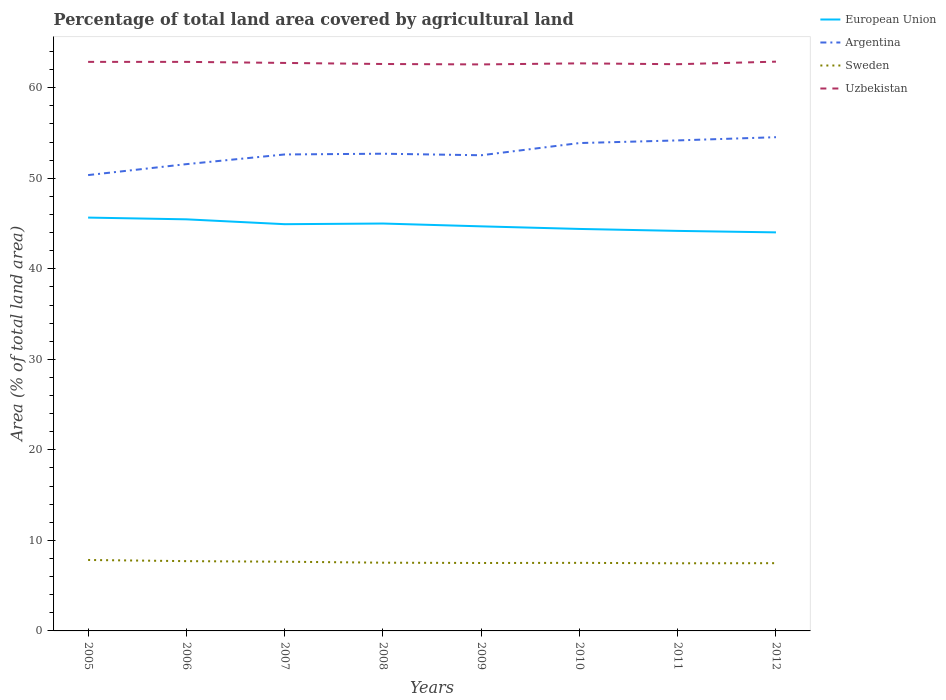Does the line corresponding to Argentina intersect with the line corresponding to Uzbekistan?
Provide a succinct answer. No. Is the number of lines equal to the number of legend labels?
Provide a short and direct response. Yes. Across all years, what is the maximum percentage of agricultural land in Uzbekistan?
Your answer should be compact. 62.58. In which year was the percentage of agricultural land in Uzbekistan maximum?
Make the answer very short. 2009. What is the total percentage of agricultural land in European Union in the graph?
Ensure brevity in your answer.  0.67. What is the difference between the highest and the second highest percentage of agricultural land in European Union?
Make the answer very short. 1.63. What is the difference between the highest and the lowest percentage of agricultural land in European Union?
Your answer should be compact. 4. How many lines are there?
Give a very brief answer. 4. What is the difference between two consecutive major ticks on the Y-axis?
Your answer should be very brief. 10. Are the values on the major ticks of Y-axis written in scientific E-notation?
Keep it short and to the point. No. Where does the legend appear in the graph?
Your answer should be compact. Top right. How are the legend labels stacked?
Give a very brief answer. Vertical. What is the title of the graph?
Provide a succinct answer. Percentage of total land area covered by agricultural land. What is the label or title of the X-axis?
Ensure brevity in your answer.  Years. What is the label or title of the Y-axis?
Offer a very short reply. Area (% of total land area). What is the Area (% of total land area) of European Union in 2005?
Keep it short and to the point. 45.66. What is the Area (% of total land area) in Argentina in 2005?
Provide a short and direct response. 50.35. What is the Area (% of total land area) of Sweden in 2005?
Offer a terse response. 7.84. What is the Area (% of total land area) in Uzbekistan in 2005?
Provide a short and direct response. 62.86. What is the Area (% of total land area) of European Union in 2006?
Your answer should be very brief. 45.47. What is the Area (% of total land area) of Argentina in 2006?
Your response must be concise. 51.56. What is the Area (% of total land area) in Sweden in 2006?
Ensure brevity in your answer.  7.71. What is the Area (% of total land area) in Uzbekistan in 2006?
Your answer should be very brief. 62.86. What is the Area (% of total land area) of European Union in 2007?
Offer a terse response. 44.93. What is the Area (% of total land area) in Argentina in 2007?
Give a very brief answer. 52.63. What is the Area (% of total land area) of Sweden in 2007?
Ensure brevity in your answer.  7.64. What is the Area (% of total land area) of Uzbekistan in 2007?
Offer a very short reply. 62.74. What is the Area (% of total land area) of European Union in 2008?
Offer a very short reply. 45. What is the Area (% of total land area) in Argentina in 2008?
Offer a terse response. 52.71. What is the Area (% of total land area) in Sweden in 2008?
Give a very brief answer. 7.54. What is the Area (% of total land area) of Uzbekistan in 2008?
Your answer should be very brief. 62.62. What is the Area (% of total land area) of European Union in 2009?
Provide a short and direct response. 44.69. What is the Area (% of total land area) of Argentina in 2009?
Make the answer very short. 52.54. What is the Area (% of total land area) of Sweden in 2009?
Your answer should be very brief. 7.5. What is the Area (% of total land area) of Uzbekistan in 2009?
Offer a terse response. 62.58. What is the Area (% of total land area) of European Union in 2010?
Offer a terse response. 44.4. What is the Area (% of total land area) in Argentina in 2010?
Make the answer very short. 53.89. What is the Area (% of total land area) in Sweden in 2010?
Your answer should be compact. 7.52. What is the Area (% of total land area) of Uzbekistan in 2010?
Give a very brief answer. 62.69. What is the Area (% of total land area) of European Union in 2011?
Offer a very short reply. 44.19. What is the Area (% of total land area) of Argentina in 2011?
Make the answer very short. 54.18. What is the Area (% of total land area) in Sweden in 2011?
Make the answer very short. 7.47. What is the Area (% of total land area) of Uzbekistan in 2011?
Ensure brevity in your answer.  62.6. What is the Area (% of total land area) in European Union in 2012?
Make the answer very short. 44.02. What is the Area (% of total land area) of Argentina in 2012?
Your answer should be very brief. 54.54. What is the Area (% of total land area) in Sweden in 2012?
Offer a very short reply. 7.48. What is the Area (% of total land area) in Uzbekistan in 2012?
Make the answer very short. 62.88. Across all years, what is the maximum Area (% of total land area) in European Union?
Keep it short and to the point. 45.66. Across all years, what is the maximum Area (% of total land area) in Argentina?
Make the answer very short. 54.54. Across all years, what is the maximum Area (% of total land area) of Sweden?
Keep it short and to the point. 7.84. Across all years, what is the maximum Area (% of total land area) of Uzbekistan?
Provide a short and direct response. 62.88. Across all years, what is the minimum Area (% of total land area) of European Union?
Make the answer very short. 44.02. Across all years, what is the minimum Area (% of total land area) of Argentina?
Give a very brief answer. 50.35. Across all years, what is the minimum Area (% of total land area) of Sweden?
Offer a very short reply. 7.47. Across all years, what is the minimum Area (% of total land area) in Uzbekistan?
Keep it short and to the point. 62.58. What is the total Area (% of total land area) of European Union in the graph?
Your response must be concise. 358.36. What is the total Area (% of total land area) in Argentina in the graph?
Your answer should be very brief. 422.41. What is the total Area (% of total land area) of Sweden in the graph?
Your response must be concise. 60.71. What is the total Area (% of total land area) in Uzbekistan in the graph?
Provide a succinct answer. 501.83. What is the difference between the Area (% of total land area) in European Union in 2005 and that in 2006?
Offer a very short reply. 0.19. What is the difference between the Area (% of total land area) in Argentina in 2005 and that in 2006?
Provide a succinct answer. -1.21. What is the difference between the Area (% of total land area) in Sweden in 2005 and that in 2006?
Provide a short and direct response. 0.13. What is the difference between the Area (% of total land area) in European Union in 2005 and that in 2007?
Provide a succinct answer. 0.73. What is the difference between the Area (% of total land area) in Argentina in 2005 and that in 2007?
Make the answer very short. -2.28. What is the difference between the Area (% of total land area) in Sweden in 2005 and that in 2007?
Your answer should be very brief. 0.19. What is the difference between the Area (% of total land area) of Uzbekistan in 2005 and that in 2007?
Keep it short and to the point. 0.12. What is the difference between the Area (% of total land area) in European Union in 2005 and that in 2008?
Give a very brief answer. 0.66. What is the difference between the Area (% of total land area) of Argentina in 2005 and that in 2008?
Your answer should be compact. -2.36. What is the difference between the Area (% of total land area) in Sweden in 2005 and that in 2008?
Your answer should be compact. 0.3. What is the difference between the Area (% of total land area) in Uzbekistan in 2005 and that in 2008?
Offer a very short reply. 0.24. What is the difference between the Area (% of total land area) in European Union in 2005 and that in 2009?
Give a very brief answer. 0.97. What is the difference between the Area (% of total land area) of Argentina in 2005 and that in 2009?
Offer a terse response. -2.19. What is the difference between the Area (% of total land area) in Sweden in 2005 and that in 2009?
Offer a very short reply. 0.33. What is the difference between the Area (% of total land area) in Uzbekistan in 2005 and that in 2009?
Give a very brief answer. 0.28. What is the difference between the Area (% of total land area) of European Union in 2005 and that in 2010?
Ensure brevity in your answer.  1.25. What is the difference between the Area (% of total land area) of Argentina in 2005 and that in 2010?
Provide a succinct answer. -3.54. What is the difference between the Area (% of total land area) of Sweden in 2005 and that in 2010?
Your response must be concise. 0.32. What is the difference between the Area (% of total land area) in Uzbekistan in 2005 and that in 2010?
Your response must be concise. 0.16. What is the difference between the Area (% of total land area) of European Union in 2005 and that in 2011?
Keep it short and to the point. 1.47. What is the difference between the Area (% of total land area) in Argentina in 2005 and that in 2011?
Give a very brief answer. -3.83. What is the difference between the Area (% of total land area) in Sweden in 2005 and that in 2011?
Provide a succinct answer. 0.37. What is the difference between the Area (% of total land area) in Uzbekistan in 2005 and that in 2011?
Ensure brevity in your answer.  0.26. What is the difference between the Area (% of total land area) in European Union in 2005 and that in 2012?
Your response must be concise. 1.63. What is the difference between the Area (% of total land area) in Argentina in 2005 and that in 2012?
Keep it short and to the point. -4.19. What is the difference between the Area (% of total land area) in Sweden in 2005 and that in 2012?
Offer a very short reply. 0.35. What is the difference between the Area (% of total land area) of Uzbekistan in 2005 and that in 2012?
Provide a succinct answer. -0.02. What is the difference between the Area (% of total land area) in European Union in 2006 and that in 2007?
Provide a succinct answer. 0.54. What is the difference between the Area (% of total land area) of Argentina in 2006 and that in 2007?
Your answer should be compact. -1.07. What is the difference between the Area (% of total land area) in Sweden in 2006 and that in 2007?
Offer a terse response. 0.06. What is the difference between the Area (% of total land area) of Uzbekistan in 2006 and that in 2007?
Offer a very short reply. 0.12. What is the difference between the Area (% of total land area) of European Union in 2006 and that in 2008?
Provide a short and direct response. 0.46. What is the difference between the Area (% of total land area) in Argentina in 2006 and that in 2008?
Keep it short and to the point. -1.15. What is the difference between the Area (% of total land area) in Sweden in 2006 and that in 2008?
Provide a short and direct response. 0.17. What is the difference between the Area (% of total land area) in Uzbekistan in 2006 and that in 2008?
Make the answer very short. 0.24. What is the difference between the Area (% of total land area) in European Union in 2006 and that in 2009?
Offer a terse response. 0.78. What is the difference between the Area (% of total land area) in Argentina in 2006 and that in 2009?
Offer a very short reply. -0.98. What is the difference between the Area (% of total land area) of Sweden in 2006 and that in 2009?
Offer a very short reply. 0.2. What is the difference between the Area (% of total land area) in Uzbekistan in 2006 and that in 2009?
Keep it short and to the point. 0.28. What is the difference between the Area (% of total land area) of European Union in 2006 and that in 2010?
Keep it short and to the point. 1.06. What is the difference between the Area (% of total land area) of Argentina in 2006 and that in 2010?
Offer a very short reply. -2.33. What is the difference between the Area (% of total land area) of Sweden in 2006 and that in 2010?
Provide a short and direct response. 0.19. What is the difference between the Area (% of total land area) in Uzbekistan in 2006 and that in 2010?
Ensure brevity in your answer.  0.16. What is the difference between the Area (% of total land area) in European Union in 2006 and that in 2011?
Your response must be concise. 1.28. What is the difference between the Area (% of total land area) in Argentina in 2006 and that in 2011?
Ensure brevity in your answer.  -2.62. What is the difference between the Area (% of total land area) in Sweden in 2006 and that in 2011?
Ensure brevity in your answer.  0.24. What is the difference between the Area (% of total land area) in Uzbekistan in 2006 and that in 2011?
Your answer should be very brief. 0.26. What is the difference between the Area (% of total land area) in European Union in 2006 and that in 2012?
Ensure brevity in your answer.  1.44. What is the difference between the Area (% of total land area) of Argentina in 2006 and that in 2012?
Make the answer very short. -2.98. What is the difference between the Area (% of total land area) of Sweden in 2006 and that in 2012?
Your answer should be very brief. 0.22. What is the difference between the Area (% of total land area) of Uzbekistan in 2006 and that in 2012?
Offer a very short reply. -0.02. What is the difference between the Area (% of total land area) of European Union in 2007 and that in 2008?
Provide a succinct answer. -0.07. What is the difference between the Area (% of total land area) in Argentina in 2007 and that in 2008?
Your response must be concise. -0.08. What is the difference between the Area (% of total land area) in Sweden in 2007 and that in 2008?
Your answer should be compact. 0.11. What is the difference between the Area (% of total land area) in Uzbekistan in 2007 and that in 2008?
Offer a very short reply. 0.12. What is the difference between the Area (% of total land area) in European Union in 2007 and that in 2009?
Keep it short and to the point. 0.24. What is the difference between the Area (% of total land area) in Argentina in 2007 and that in 2009?
Your answer should be very brief. 0.09. What is the difference between the Area (% of total land area) in Sweden in 2007 and that in 2009?
Provide a short and direct response. 0.14. What is the difference between the Area (% of total land area) in Uzbekistan in 2007 and that in 2009?
Your response must be concise. 0.16. What is the difference between the Area (% of total land area) of European Union in 2007 and that in 2010?
Provide a succinct answer. 0.52. What is the difference between the Area (% of total land area) of Argentina in 2007 and that in 2010?
Your response must be concise. -1.26. What is the difference between the Area (% of total land area) in Sweden in 2007 and that in 2010?
Your answer should be compact. 0.13. What is the difference between the Area (% of total land area) in Uzbekistan in 2007 and that in 2010?
Your answer should be compact. 0.05. What is the difference between the Area (% of total land area) in European Union in 2007 and that in 2011?
Your answer should be very brief. 0.74. What is the difference between the Area (% of total land area) of Argentina in 2007 and that in 2011?
Provide a short and direct response. -1.55. What is the difference between the Area (% of total land area) in Sweden in 2007 and that in 2011?
Offer a terse response. 0.17. What is the difference between the Area (% of total land area) in Uzbekistan in 2007 and that in 2011?
Keep it short and to the point. 0.14. What is the difference between the Area (% of total land area) in European Union in 2007 and that in 2012?
Offer a terse response. 0.9. What is the difference between the Area (% of total land area) of Argentina in 2007 and that in 2012?
Ensure brevity in your answer.  -1.91. What is the difference between the Area (% of total land area) in Sweden in 2007 and that in 2012?
Provide a succinct answer. 0.16. What is the difference between the Area (% of total land area) of Uzbekistan in 2007 and that in 2012?
Make the answer very short. -0.14. What is the difference between the Area (% of total land area) of European Union in 2008 and that in 2009?
Your response must be concise. 0.31. What is the difference between the Area (% of total land area) of Argentina in 2008 and that in 2009?
Provide a short and direct response. 0.17. What is the difference between the Area (% of total land area) in Sweden in 2008 and that in 2009?
Your response must be concise. 0.03. What is the difference between the Area (% of total land area) of Uzbekistan in 2008 and that in 2009?
Offer a very short reply. 0.05. What is the difference between the Area (% of total land area) in European Union in 2008 and that in 2010?
Keep it short and to the point. 0.6. What is the difference between the Area (% of total land area) in Argentina in 2008 and that in 2010?
Give a very brief answer. -1.18. What is the difference between the Area (% of total land area) of Sweden in 2008 and that in 2010?
Your response must be concise. 0.02. What is the difference between the Area (% of total land area) of Uzbekistan in 2008 and that in 2010?
Give a very brief answer. -0.07. What is the difference between the Area (% of total land area) in European Union in 2008 and that in 2011?
Make the answer very short. 0.81. What is the difference between the Area (% of total land area) in Argentina in 2008 and that in 2011?
Keep it short and to the point. -1.47. What is the difference between the Area (% of total land area) of Sweden in 2008 and that in 2011?
Your response must be concise. 0.07. What is the difference between the Area (% of total land area) of Uzbekistan in 2008 and that in 2011?
Provide a short and direct response. 0.02. What is the difference between the Area (% of total land area) in European Union in 2008 and that in 2012?
Provide a short and direct response. 0.98. What is the difference between the Area (% of total land area) in Argentina in 2008 and that in 2012?
Your answer should be very brief. -1.82. What is the difference between the Area (% of total land area) of Sweden in 2008 and that in 2012?
Offer a terse response. 0.05. What is the difference between the Area (% of total land area) of Uzbekistan in 2008 and that in 2012?
Provide a short and direct response. -0.26. What is the difference between the Area (% of total land area) in European Union in 2009 and that in 2010?
Make the answer very short. 0.29. What is the difference between the Area (% of total land area) in Argentina in 2009 and that in 2010?
Make the answer very short. -1.35. What is the difference between the Area (% of total land area) in Sweden in 2009 and that in 2010?
Your answer should be very brief. -0.01. What is the difference between the Area (% of total land area) in Uzbekistan in 2009 and that in 2010?
Give a very brief answer. -0.12. What is the difference between the Area (% of total land area) in European Union in 2009 and that in 2011?
Ensure brevity in your answer.  0.5. What is the difference between the Area (% of total land area) in Argentina in 2009 and that in 2011?
Give a very brief answer. -1.64. What is the difference between the Area (% of total land area) in Sweden in 2009 and that in 2011?
Ensure brevity in your answer.  0.03. What is the difference between the Area (% of total land area) of Uzbekistan in 2009 and that in 2011?
Provide a short and direct response. -0.02. What is the difference between the Area (% of total land area) in European Union in 2009 and that in 2012?
Give a very brief answer. 0.67. What is the difference between the Area (% of total land area) in Argentina in 2009 and that in 2012?
Offer a very short reply. -2. What is the difference between the Area (% of total land area) of Sweden in 2009 and that in 2012?
Your response must be concise. 0.02. What is the difference between the Area (% of total land area) in Uzbekistan in 2009 and that in 2012?
Your answer should be compact. -0.31. What is the difference between the Area (% of total land area) of European Union in 2010 and that in 2011?
Provide a succinct answer. 0.22. What is the difference between the Area (% of total land area) of Argentina in 2010 and that in 2011?
Provide a succinct answer. -0.29. What is the difference between the Area (% of total land area) in Sweden in 2010 and that in 2011?
Provide a succinct answer. 0.05. What is the difference between the Area (% of total land area) in Uzbekistan in 2010 and that in 2011?
Offer a terse response. 0.09. What is the difference between the Area (% of total land area) of European Union in 2010 and that in 2012?
Ensure brevity in your answer.  0.38. What is the difference between the Area (% of total land area) in Argentina in 2010 and that in 2012?
Give a very brief answer. -0.65. What is the difference between the Area (% of total land area) in Sweden in 2010 and that in 2012?
Provide a succinct answer. 0.03. What is the difference between the Area (% of total land area) in Uzbekistan in 2010 and that in 2012?
Provide a succinct answer. -0.19. What is the difference between the Area (% of total land area) in European Union in 2011 and that in 2012?
Offer a very short reply. 0.16. What is the difference between the Area (% of total land area) of Argentina in 2011 and that in 2012?
Ensure brevity in your answer.  -0.36. What is the difference between the Area (% of total land area) in Sweden in 2011 and that in 2012?
Make the answer very short. -0.01. What is the difference between the Area (% of total land area) in Uzbekistan in 2011 and that in 2012?
Ensure brevity in your answer.  -0.28. What is the difference between the Area (% of total land area) of European Union in 2005 and the Area (% of total land area) of Argentina in 2006?
Offer a terse response. -5.9. What is the difference between the Area (% of total land area) of European Union in 2005 and the Area (% of total land area) of Sweden in 2006?
Offer a terse response. 37.95. What is the difference between the Area (% of total land area) of European Union in 2005 and the Area (% of total land area) of Uzbekistan in 2006?
Give a very brief answer. -17.2. What is the difference between the Area (% of total land area) of Argentina in 2005 and the Area (% of total land area) of Sweden in 2006?
Ensure brevity in your answer.  42.64. What is the difference between the Area (% of total land area) of Argentina in 2005 and the Area (% of total land area) of Uzbekistan in 2006?
Your answer should be very brief. -12.51. What is the difference between the Area (% of total land area) of Sweden in 2005 and the Area (% of total land area) of Uzbekistan in 2006?
Make the answer very short. -55.02. What is the difference between the Area (% of total land area) of European Union in 2005 and the Area (% of total land area) of Argentina in 2007?
Your answer should be very brief. -6.97. What is the difference between the Area (% of total land area) in European Union in 2005 and the Area (% of total land area) in Sweden in 2007?
Ensure brevity in your answer.  38.01. What is the difference between the Area (% of total land area) in European Union in 2005 and the Area (% of total land area) in Uzbekistan in 2007?
Offer a very short reply. -17.08. What is the difference between the Area (% of total land area) in Argentina in 2005 and the Area (% of total land area) in Sweden in 2007?
Provide a succinct answer. 42.71. What is the difference between the Area (% of total land area) of Argentina in 2005 and the Area (% of total land area) of Uzbekistan in 2007?
Make the answer very short. -12.39. What is the difference between the Area (% of total land area) of Sweden in 2005 and the Area (% of total land area) of Uzbekistan in 2007?
Keep it short and to the point. -54.9. What is the difference between the Area (% of total land area) of European Union in 2005 and the Area (% of total land area) of Argentina in 2008?
Offer a terse response. -7.06. What is the difference between the Area (% of total land area) in European Union in 2005 and the Area (% of total land area) in Sweden in 2008?
Provide a short and direct response. 38.12. What is the difference between the Area (% of total land area) in European Union in 2005 and the Area (% of total land area) in Uzbekistan in 2008?
Offer a terse response. -16.97. What is the difference between the Area (% of total land area) in Argentina in 2005 and the Area (% of total land area) in Sweden in 2008?
Give a very brief answer. 42.81. What is the difference between the Area (% of total land area) of Argentina in 2005 and the Area (% of total land area) of Uzbekistan in 2008?
Make the answer very short. -12.27. What is the difference between the Area (% of total land area) in Sweden in 2005 and the Area (% of total land area) in Uzbekistan in 2008?
Your response must be concise. -54.79. What is the difference between the Area (% of total land area) in European Union in 2005 and the Area (% of total land area) in Argentina in 2009?
Make the answer very short. -6.88. What is the difference between the Area (% of total land area) of European Union in 2005 and the Area (% of total land area) of Sweden in 2009?
Offer a very short reply. 38.15. What is the difference between the Area (% of total land area) in European Union in 2005 and the Area (% of total land area) in Uzbekistan in 2009?
Your answer should be compact. -16.92. What is the difference between the Area (% of total land area) in Argentina in 2005 and the Area (% of total land area) in Sweden in 2009?
Your answer should be very brief. 42.85. What is the difference between the Area (% of total land area) of Argentina in 2005 and the Area (% of total land area) of Uzbekistan in 2009?
Give a very brief answer. -12.22. What is the difference between the Area (% of total land area) of Sweden in 2005 and the Area (% of total land area) of Uzbekistan in 2009?
Make the answer very short. -54.74. What is the difference between the Area (% of total land area) in European Union in 2005 and the Area (% of total land area) in Argentina in 2010?
Your answer should be very brief. -8.23. What is the difference between the Area (% of total land area) in European Union in 2005 and the Area (% of total land area) in Sweden in 2010?
Offer a terse response. 38.14. What is the difference between the Area (% of total land area) in European Union in 2005 and the Area (% of total land area) in Uzbekistan in 2010?
Ensure brevity in your answer.  -17.04. What is the difference between the Area (% of total land area) of Argentina in 2005 and the Area (% of total land area) of Sweden in 2010?
Your answer should be compact. 42.83. What is the difference between the Area (% of total land area) of Argentina in 2005 and the Area (% of total land area) of Uzbekistan in 2010?
Keep it short and to the point. -12.34. What is the difference between the Area (% of total land area) in Sweden in 2005 and the Area (% of total land area) in Uzbekistan in 2010?
Offer a very short reply. -54.86. What is the difference between the Area (% of total land area) of European Union in 2005 and the Area (% of total land area) of Argentina in 2011?
Keep it short and to the point. -8.52. What is the difference between the Area (% of total land area) of European Union in 2005 and the Area (% of total land area) of Sweden in 2011?
Offer a terse response. 38.19. What is the difference between the Area (% of total land area) in European Union in 2005 and the Area (% of total land area) in Uzbekistan in 2011?
Offer a very short reply. -16.94. What is the difference between the Area (% of total land area) of Argentina in 2005 and the Area (% of total land area) of Sweden in 2011?
Your answer should be very brief. 42.88. What is the difference between the Area (% of total land area) of Argentina in 2005 and the Area (% of total land area) of Uzbekistan in 2011?
Keep it short and to the point. -12.25. What is the difference between the Area (% of total land area) of Sweden in 2005 and the Area (% of total land area) of Uzbekistan in 2011?
Provide a short and direct response. -54.76. What is the difference between the Area (% of total land area) in European Union in 2005 and the Area (% of total land area) in Argentina in 2012?
Keep it short and to the point. -8.88. What is the difference between the Area (% of total land area) in European Union in 2005 and the Area (% of total land area) in Sweden in 2012?
Offer a very short reply. 38.17. What is the difference between the Area (% of total land area) of European Union in 2005 and the Area (% of total land area) of Uzbekistan in 2012?
Provide a short and direct response. -17.22. What is the difference between the Area (% of total land area) in Argentina in 2005 and the Area (% of total land area) in Sweden in 2012?
Give a very brief answer. 42.87. What is the difference between the Area (% of total land area) in Argentina in 2005 and the Area (% of total land area) in Uzbekistan in 2012?
Your answer should be compact. -12.53. What is the difference between the Area (% of total land area) in Sweden in 2005 and the Area (% of total land area) in Uzbekistan in 2012?
Ensure brevity in your answer.  -55.04. What is the difference between the Area (% of total land area) in European Union in 2006 and the Area (% of total land area) in Argentina in 2007?
Offer a very short reply. -7.17. What is the difference between the Area (% of total land area) of European Union in 2006 and the Area (% of total land area) of Sweden in 2007?
Ensure brevity in your answer.  37.82. What is the difference between the Area (% of total land area) of European Union in 2006 and the Area (% of total land area) of Uzbekistan in 2007?
Your answer should be compact. -17.28. What is the difference between the Area (% of total land area) in Argentina in 2006 and the Area (% of total land area) in Sweden in 2007?
Your response must be concise. 43.92. What is the difference between the Area (% of total land area) of Argentina in 2006 and the Area (% of total land area) of Uzbekistan in 2007?
Your response must be concise. -11.18. What is the difference between the Area (% of total land area) of Sweden in 2006 and the Area (% of total land area) of Uzbekistan in 2007?
Offer a very short reply. -55.03. What is the difference between the Area (% of total land area) in European Union in 2006 and the Area (% of total land area) in Argentina in 2008?
Ensure brevity in your answer.  -7.25. What is the difference between the Area (% of total land area) in European Union in 2006 and the Area (% of total land area) in Sweden in 2008?
Your answer should be compact. 37.93. What is the difference between the Area (% of total land area) of European Union in 2006 and the Area (% of total land area) of Uzbekistan in 2008?
Provide a succinct answer. -17.16. What is the difference between the Area (% of total land area) of Argentina in 2006 and the Area (% of total land area) of Sweden in 2008?
Offer a terse response. 44.02. What is the difference between the Area (% of total land area) of Argentina in 2006 and the Area (% of total land area) of Uzbekistan in 2008?
Your answer should be very brief. -11.06. What is the difference between the Area (% of total land area) in Sweden in 2006 and the Area (% of total land area) in Uzbekistan in 2008?
Make the answer very short. -54.92. What is the difference between the Area (% of total land area) of European Union in 2006 and the Area (% of total land area) of Argentina in 2009?
Give a very brief answer. -7.08. What is the difference between the Area (% of total land area) of European Union in 2006 and the Area (% of total land area) of Sweden in 2009?
Provide a short and direct response. 37.96. What is the difference between the Area (% of total land area) of European Union in 2006 and the Area (% of total land area) of Uzbekistan in 2009?
Provide a short and direct response. -17.11. What is the difference between the Area (% of total land area) of Argentina in 2006 and the Area (% of total land area) of Sweden in 2009?
Ensure brevity in your answer.  44.06. What is the difference between the Area (% of total land area) of Argentina in 2006 and the Area (% of total land area) of Uzbekistan in 2009?
Keep it short and to the point. -11.02. What is the difference between the Area (% of total land area) in Sweden in 2006 and the Area (% of total land area) in Uzbekistan in 2009?
Make the answer very short. -54.87. What is the difference between the Area (% of total land area) of European Union in 2006 and the Area (% of total land area) of Argentina in 2010?
Offer a very short reply. -8.43. What is the difference between the Area (% of total land area) of European Union in 2006 and the Area (% of total land area) of Sweden in 2010?
Offer a very short reply. 37.95. What is the difference between the Area (% of total land area) in European Union in 2006 and the Area (% of total land area) in Uzbekistan in 2010?
Ensure brevity in your answer.  -17.23. What is the difference between the Area (% of total land area) in Argentina in 2006 and the Area (% of total land area) in Sweden in 2010?
Ensure brevity in your answer.  44.04. What is the difference between the Area (% of total land area) of Argentina in 2006 and the Area (% of total land area) of Uzbekistan in 2010?
Your answer should be compact. -11.13. What is the difference between the Area (% of total land area) in Sweden in 2006 and the Area (% of total land area) in Uzbekistan in 2010?
Ensure brevity in your answer.  -54.99. What is the difference between the Area (% of total land area) of European Union in 2006 and the Area (% of total land area) of Argentina in 2011?
Provide a short and direct response. -8.72. What is the difference between the Area (% of total land area) of European Union in 2006 and the Area (% of total land area) of Sweden in 2011?
Give a very brief answer. 37.99. What is the difference between the Area (% of total land area) in European Union in 2006 and the Area (% of total land area) in Uzbekistan in 2011?
Your response must be concise. -17.13. What is the difference between the Area (% of total land area) of Argentina in 2006 and the Area (% of total land area) of Sweden in 2011?
Offer a terse response. 44.09. What is the difference between the Area (% of total land area) of Argentina in 2006 and the Area (% of total land area) of Uzbekistan in 2011?
Offer a very short reply. -11.04. What is the difference between the Area (% of total land area) of Sweden in 2006 and the Area (% of total land area) of Uzbekistan in 2011?
Offer a terse response. -54.89. What is the difference between the Area (% of total land area) in European Union in 2006 and the Area (% of total land area) in Argentina in 2012?
Keep it short and to the point. -9.07. What is the difference between the Area (% of total land area) in European Union in 2006 and the Area (% of total land area) in Sweden in 2012?
Give a very brief answer. 37.98. What is the difference between the Area (% of total land area) in European Union in 2006 and the Area (% of total land area) in Uzbekistan in 2012?
Make the answer very short. -17.42. What is the difference between the Area (% of total land area) in Argentina in 2006 and the Area (% of total land area) in Sweden in 2012?
Your answer should be compact. 44.08. What is the difference between the Area (% of total land area) in Argentina in 2006 and the Area (% of total land area) in Uzbekistan in 2012?
Offer a terse response. -11.32. What is the difference between the Area (% of total land area) in Sweden in 2006 and the Area (% of total land area) in Uzbekistan in 2012?
Your answer should be compact. -55.17. What is the difference between the Area (% of total land area) in European Union in 2007 and the Area (% of total land area) in Argentina in 2008?
Ensure brevity in your answer.  -7.79. What is the difference between the Area (% of total land area) in European Union in 2007 and the Area (% of total land area) in Sweden in 2008?
Your response must be concise. 37.39. What is the difference between the Area (% of total land area) of European Union in 2007 and the Area (% of total land area) of Uzbekistan in 2008?
Your response must be concise. -17.7. What is the difference between the Area (% of total land area) of Argentina in 2007 and the Area (% of total land area) of Sweden in 2008?
Your answer should be compact. 45.09. What is the difference between the Area (% of total land area) of Argentina in 2007 and the Area (% of total land area) of Uzbekistan in 2008?
Provide a short and direct response. -9.99. What is the difference between the Area (% of total land area) in Sweden in 2007 and the Area (% of total land area) in Uzbekistan in 2008?
Keep it short and to the point. -54.98. What is the difference between the Area (% of total land area) of European Union in 2007 and the Area (% of total land area) of Argentina in 2009?
Make the answer very short. -7.61. What is the difference between the Area (% of total land area) of European Union in 2007 and the Area (% of total land area) of Sweden in 2009?
Provide a short and direct response. 37.42. What is the difference between the Area (% of total land area) of European Union in 2007 and the Area (% of total land area) of Uzbekistan in 2009?
Keep it short and to the point. -17.65. What is the difference between the Area (% of total land area) in Argentina in 2007 and the Area (% of total land area) in Sweden in 2009?
Provide a short and direct response. 45.13. What is the difference between the Area (% of total land area) in Argentina in 2007 and the Area (% of total land area) in Uzbekistan in 2009?
Your answer should be compact. -9.95. What is the difference between the Area (% of total land area) of Sweden in 2007 and the Area (% of total land area) of Uzbekistan in 2009?
Keep it short and to the point. -54.93. What is the difference between the Area (% of total land area) in European Union in 2007 and the Area (% of total land area) in Argentina in 2010?
Offer a terse response. -8.96. What is the difference between the Area (% of total land area) of European Union in 2007 and the Area (% of total land area) of Sweden in 2010?
Provide a short and direct response. 37.41. What is the difference between the Area (% of total land area) of European Union in 2007 and the Area (% of total land area) of Uzbekistan in 2010?
Offer a terse response. -17.77. What is the difference between the Area (% of total land area) of Argentina in 2007 and the Area (% of total land area) of Sweden in 2010?
Ensure brevity in your answer.  45.11. What is the difference between the Area (% of total land area) of Argentina in 2007 and the Area (% of total land area) of Uzbekistan in 2010?
Provide a short and direct response. -10.06. What is the difference between the Area (% of total land area) in Sweden in 2007 and the Area (% of total land area) in Uzbekistan in 2010?
Ensure brevity in your answer.  -55.05. What is the difference between the Area (% of total land area) in European Union in 2007 and the Area (% of total land area) in Argentina in 2011?
Ensure brevity in your answer.  -9.25. What is the difference between the Area (% of total land area) in European Union in 2007 and the Area (% of total land area) in Sweden in 2011?
Provide a succinct answer. 37.46. What is the difference between the Area (% of total land area) of European Union in 2007 and the Area (% of total land area) of Uzbekistan in 2011?
Provide a short and direct response. -17.67. What is the difference between the Area (% of total land area) in Argentina in 2007 and the Area (% of total land area) in Sweden in 2011?
Make the answer very short. 45.16. What is the difference between the Area (% of total land area) of Argentina in 2007 and the Area (% of total land area) of Uzbekistan in 2011?
Ensure brevity in your answer.  -9.97. What is the difference between the Area (% of total land area) in Sweden in 2007 and the Area (% of total land area) in Uzbekistan in 2011?
Provide a succinct answer. -54.95. What is the difference between the Area (% of total land area) in European Union in 2007 and the Area (% of total land area) in Argentina in 2012?
Make the answer very short. -9.61. What is the difference between the Area (% of total land area) of European Union in 2007 and the Area (% of total land area) of Sweden in 2012?
Ensure brevity in your answer.  37.44. What is the difference between the Area (% of total land area) in European Union in 2007 and the Area (% of total land area) in Uzbekistan in 2012?
Your answer should be compact. -17.95. What is the difference between the Area (% of total land area) in Argentina in 2007 and the Area (% of total land area) in Sweden in 2012?
Keep it short and to the point. 45.15. What is the difference between the Area (% of total land area) of Argentina in 2007 and the Area (% of total land area) of Uzbekistan in 2012?
Provide a succinct answer. -10.25. What is the difference between the Area (% of total land area) of Sweden in 2007 and the Area (% of total land area) of Uzbekistan in 2012?
Offer a very short reply. -55.24. What is the difference between the Area (% of total land area) in European Union in 2008 and the Area (% of total land area) in Argentina in 2009?
Make the answer very short. -7.54. What is the difference between the Area (% of total land area) in European Union in 2008 and the Area (% of total land area) in Sweden in 2009?
Provide a succinct answer. 37.5. What is the difference between the Area (% of total land area) in European Union in 2008 and the Area (% of total land area) in Uzbekistan in 2009?
Offer a very short reply. -17.58. What is the difference between the Area (% of total land area) of Argentina in 2008 and the Area (% of total land area) of Sweden in 2009?
Keep it short and to the point. 45.21. What is the difference between the Area (% of total land area) in Argentina in 2008 and the Area (% of total land area) in Uzbekistan in 2009?
Give a very brief answer. -9.86. What is the difference between the Area (% of total land area) of Sweden in 2008 and the Area (% of total land area) of Uzbekistan in 2009?
Offer a very short reply. -55.04. What is the difference between the Area (% of total land area) in European Union in 2008 and the Area (% of total land area) in Argentina in 2010?
Provide a short and direct response. -8.89. What is the difference between the Area (% of total land area) in European Union in 2008 and the Area (% of total land area) in Sweden in 2010?
Give a very brief answer. 37.48. What is the difference between the Area (% of total land area) in European Union in 2008 and the Area (% of total land area) in Uzbekistan in 2010?
Provide a succinct answer. -17.69. What is the difference between the Area (% of total land area) of Argentina in 2008 and the Area (% of total land area) of Sweden in 2010?
Give a very brief answer. 45.2. What is the difference between the Area (% of total land area) in Argentina in 2008 and the Area (% of total land area) in Uzbekistan in 2010?
Your answer should be compact. -9.98. What is the difference between the Area (% of total land area) of Sweden in 2008 and the Area (% of total land area) of Uzbekistan in 2010?
Your answer should be compact. -55.16. What is the difference between the Area (% of total land area) of European Union in 2008 and the Area (% of total land area) of Argentina in 2011?
Your response must be concise. -9.18. What is the difference between the Area (% of total land area) in European Union in 2008 and the Area (% of total land area) in Sweden in 2011?
Provide a short and direct response. 37.53. What is the difference between the Area (% of total land area) of European Union in 2008 and the Area (% of total land area) of Uzbekistan in 2011?
Keep it short and to the point. -17.6. What is the difference between the Area (% of total land area) of Argentina in 2008 and the Area (% of total land area) of Sweden in 2011?
Offer a terse response. 45.24. What is the difference between the Area (% of total land area) in Argentina in 2008 and the Area (% of total land area) in Uzbekistan in 2011?
Ensure brevity in your answer.  -9.89. What is the difference between the Area (% of total land area) of Sweden in 2008 and the Area (% of total land area) of Uzbekistan in 2011?
Offer a very short reply. -55.06. What is the difference between the Area (% of total land area) of European Union in 2008 and the Area (% of total land area) of Argentina in 2012?
Your answer should be compact. -9.54. What is the difference between the Area (% of total land area) in European Union in 2008 and the Area (% of total land area) in Sweden in 2012?
Offer a terse response. 37.52. What is the difference between the Area (% of total land area) of European Union in 2008 and the Area (% of total land area) of Uzbekistan in 2012?
Keep it short and to the point. -17.88. What is the difference between the Area (% of total land area) of Argentina in 2008 and the Area (% of total land area) of Sweden in 2012?
Offer a terse response. 45.23. What is the difference between the Area (% of total land area) in Argentina in 2008 and the Area (% of total land area) in Uzbekistan in 2012?
Provide a succinct answer. -10.17. What is the difference between the Area (% of total land area) of Sweden in 2008 and the Area (% of total land area) of Uzbekistan in 2012?
Your response must be concise. -55.34. What is the difference between the Area (% of total land area) in European Union in 2009 and the Area (% of total land area) in Argentina in 2010?
Offer a very short reply. -9.2. What is the difference between the Area (% of total land area) in European Union in 2009 and the Area (% of total land area) in Sweden in 2010?
Keep it short and to the point. 37.17. What is the difference between the Area (% of total land area) in European Union in 2009 and the Area (% of total land area) in Uzbekistan in 2010?
Your answer should be compact. -18. What is the difference between the Area (% of total land area) in Argentina in 2009 and the Area (% of total land area) in Sweden in 2010?
Your answer should be compact. 45.02. What is the difference between the Area (% of total land area) in Argentina in 2009 and the Area (% of total land area) in Uzbekistan in 2010?
Ensure brevity in your answer.  -10.15. What is the difference between the Area (% of total land area) of Sweden in 2009 and the Area (% of total land area) of Uzbekistan in 2010?
Ensure brevity in your answer.  -55.19. What is the difference between the Area (% of total land area) of European Union in 2009 and the Area (% of total land area) of Argentina in 2011?
Your answer should be very brief. -9.49. What is the difference between the Area (% of total land area) in European Union in 2009 and the Area (% of total land area) in Sweden in 2011?
Ensure brevity in your answer.  37.22. What is the difference between the Area (% of total land area) of European Union in 2009 and the Area (% of total land area) of Uzbekistan in 2011?
Provide a succinct answer. -17.91. What is the difference between the Area (% of total land area) in Argentina in 2009 and the Area (% of total land area) in Sweden in 2011?
Your response must be concise. 45.07. What is the difference between the Area (% of total land area) of Argentina in 2009 and the Area (% of total land area) of Uzbekistan in 2011?
Give a very brief answer. -10.06. What is the difference between the Area (% of total land area) of Sweden in 2009 and the Area (% of total land area) of Uzbekistan in 2011?
Provide a short and direct response. -55.1. What is the difference between the Area (% of total land area) in European Union in 2009 and the Area (% of total land area) in Argentina in 2012?
Provide a short and direct response. -9.85. What is the difference between the Area (% of total land area) of European Union in 2009 and the Area (% of total land area) of Sweden in 2012?
Your answer should be compact. 37.21. What is the difference between the Area (% of total land area) in European Union in 2009 and the Area (% of total land area) in Uzbekistan in 2012?
Ensure brevity in your answer.  -18.19. What is the difference between the Area (% of total land area) of Argentina in 2009 and the Area (% of total land area) of Sweden in 2012?
Ensure brevity in your answer.  45.06. What is the difference between the Area (% of total land area) in Argentina in 2009 and the Area (% of total land area) in Uzbekistan in 2012?
Keep it short and to the point. -10.34. What is the difference between the Area (% of total land area) of Sweden in 2009 and the Area (% of total land area) of Uzbekistan in 2012?
Give a very brief answer. -55.38. What is the difference between the Area (% of total land area) of European Union in 2010 and the Area (% of total land area) of Argentina in 2011?
Your answer should be compact. -9.78. What is the difference between the Area (% of total land area) of European Union in 2010 and the Area (% of total land area) of Sweden in 2011?
Ensure brevity in your answer.  36.93. What is the difference between the Area (% of total land area) in European Union in 2010 and the Area (% of total land area) in Uzbekistan in 2011?
Give a very brief answer. -18.2. What is the difference between the Area (% of total land area) of Argentina in 2010 and the Area (% of total land area) of Sweden in 2011?
Provide a short and direct response. 46.42. What is the difference between the Area (% of total land area) of Argentina in 2010 and the Area (% of total land area) of Uzbekistan in 2011?
Keep it short and to the point. -8.71. What is the difference between the Area (% of total land area) in Sweden in 2010 and the Area (% of total land area) in Uzbekistan in 2011?
Your response must be concise. -55.08. What is the difference between the Area (% of total land area) in European Union in 2010 and the Area (% of total land area) in Argentina in 2012?
Offer a terse response. -10.13. What is the difference between the Area (% of total land area) of European Union in 2010 and the Area (% of total land area) of Sweden in 2012?
Provide a succinct answer. 36.92. What is the difference between the Area (% of total land area) of European Union in 2010 and the Area (% of total land area) of Uzbekistan in 2012?
Ensure brevity in your answer.  -18.48. What is the difference between the Area (% of total land area) in Argentina in 2010 and the Area (% of total land area) in Sweden in 2012?
Make the answer very short. 46.41. What is the difference between the Area (% of total land area) in Argentina in 2010 and the Area (% of total land area) in Uzbekistan in 2012?
Offer a very short reply. -8.99. What is the difference between the Area (% of total land area) of Sweden in 2010 and the Area (% of total land area) of Uzbekistan in 2012?
Offer a very short reply. -55.36. What is the difference between the Area (% of total land area) of European Union in 2011 and the Area (% of total land area) of Argentina in 2012?
Offer a very short reply. -10.35. What is the difference between the Area (% of total land area) in European Union in 2011 and the Area (% of total land area) in Sweden in 2012?
Make the answer very short. 36.7. What is the difference between the Area (% of total land area) in European Union in 2011 and the Area (% of total land area) in Uzbekistan in 2012?
Your response must be concise. -18.69. What is the difference between the Area (% of total land area) of Argentina in 2011 and the Area (% of total land area) of Sweden in 2012?
Your answer should be compact. 46.7. What is the difference between the Area (% of total land area) of Argentina in 2011 and the Area (% of total land area) of Uzbekistan in 2012?
Provide a succinct answer. -8.7. What is the difference between the Area (% of total land area) of Sweden in 2011 and the Area (% of total land area) of Uzbekistan in 2012?
Your response must be concise. -55.41. What is the average Area (% of total land area) in European Union per year?
Ensure brevity in your answer.  44.79. What is the average Area (% of total land area) in Argentina per year?
Your answer should be compact. 52.8. What is the average Area (% of total land area) of Sweden per year?
Provide a short and direct response. 7.59. What is the average Area (% of total land area) in Uzbekistan per year?
Your answer should be very brief. 62.73. In the year 2005, what is the difference between the Area (% of total land area) of European Union and Area (% of total land area) of Argentina?
Keep it short and to the point. -4.69. In the year 2005, what is the difference between the Area (% of total land area) in European Union and Area (% of total land area) in Sweden?
Make the answer very short. 37.82. In the year 2005, what is the difference between the Area (% of total land area) in European Union and Area (% of total land area) in Uzbekistan?
Give a very brief answer. -17.2. In the year 2005, what is the difference between the Area (% of total land area) in Argentina and Area (% of total land area) in Sweden?
Your response must be concise. 42.51. In the year 2005, what is the difference between the Area (% of total land area) of Argentina and Area (% of total land area) of Uzbekistan?
Keep it short and to the point. -12.51. In the year 2005, what is the difference between the Area (% of total land area) in Sweden and Area (% of total land area) in Uzbekistan?
Offer a very short reply. -55.02. In the year 2006, what is the difference between the Area (% of total land area) in European Union and Area (% of total land area) in Argentina?
Your answer should be very brief. -6.09. In the year 2006, what is the difference between the Area (% of total land area) in European Union and Area (% of total land area) in Sweden?
Make the answer very short. 37.76. In the year 2006, what is the difference between the Area (% of total land area) in European Union and Area (% of total land area) in Uzbekistan?
Keep it short and to the point. -17.39. In the year 2006, what is the difference between the Area (% of total land area) in Argentina and Area (% of total land area) in Sweden?
Ensure brevity in your answer.  43.85. In the year 2006, what is the difference between the Area (% of total land area) of Argentina and Area (% of total land area) of Uzbekistan?
Make the answer very short. -11.3. In the year 2006, what is the difference between the Area (% of total land area) in Sweden and Area (% of total land area) in Uzbekistan?
Provide a short and direct response. -55.15. In the year 2007, what is the difference between the Area (% of total land area) of European Union and Area (% of total land area) of Argentina?
Your answer should be very brief. -7.7. In the year 2007, what is the difference between the Area (% of total land area) in European Union and Area (% of total land area) in Sweden?
Your answer should be compact. 37.28. In the year 2007, what is the difference between the Area (% of total land area) in European Union and Area (% of total land area) in Uzbekistan?
Give a very brief answer. -17.81. In the year 2007, what is the difference between the Area (% of total land area) of Argentina and Area (% of total land area) of Sweden?
Offer a terse response. 44.99. In the year 2007, what is the difference between the Area (% of total land area) of Argentina and Area (% of total land area) of Uzbekistan?
Provide a short and direct response. -10.11. In the year 2007, what is the difference between the Area (% of total land area) of Sweden and Area (% of total land area) of Uzbekistan?
Your answer should be compact. -55.1. In the year 2008, what is the difference between the Area (% of total land area) of European Union and Area (% of total land area) of Argentina?
Your response must be concise. -7.71. In the year 2008, what is the difference between the Area (% of total land area) in European Union and Area (% of total land area) in Sweden?
Ensure brevity in your answer.  37.46. In the year 2008, what is the difference between the Area (% of total land area) of European Union and Area (% of total land area) of Uzbekistan?
Your answer should be very brief. -17.62. In the year 2008, what is the difference between the Area (% of total land area) of Argentina and Area (% of total land area) of Sweden?
Provide a short and direct response. 45.18. In the year 2008, what is the difference between the Area (% of total land area) of Argentina and Area (% of total land area) of Uzbekistan?
Make the answer very short. -9.91. In the year 2008, what is the difference between the Area (% of total land area) in Sweden and Area (% of total land area) in Uzbekistan?
Your answer should be very brief. -55.09. In the year 2009, what is the difference between the Area (% of total land area) in European Union and Area (% of total land area) in Argentina?
Provide a short and direct response. -7.85. In the year 2009, what is the difference between the Area (% of total land area) of European Union and Area (% of total land area) of Sweden?
Your answer should be compact. 37.19. In the year 2009, what is the difference between the Area (% of total land area) of European Union and Area (% of total land area) of Uzbekistan?
Your response must be concise. -17.89. In the year 2009, what is the difference between the Area (% of total land area) in Argentina and Area (% of total land area) in Sweden?
Your answer should be compact. 45.04. In the year 2009, what is the difference between the Area (% of total land area) of Argentina and Area (% of total land area) of Uzbekistan?
Make the answer very short. -10.03. In the year 2009, what is the difference between the Area (% of total land area) in Sweden and Area (% of total land area) in Uzbekistan?
Provide a short and direct response. -55.07. In the year 2010, what is the difference between the Area (% of total land area) in European Union and Area (% of total land area) in Argentina?
Your response must be concise. -9.49. In the year 2010, what is the difference between the Area (% of total land area) of European Union and Area (% of total land area) of Sweden?
Your response must be concise. 36.89. In the year 2010, what is the difference between the Area (% of total land area) in European Union and Area (% of total land area) in Uzbekistan?
Your response must be concise. -18.29. In the year 2010, what is the difference between the Area (% of total land area) in Argentina and Area (% of total land area) in Sweden?
Give a very brief answer. 46.37. In the year 2010, what is the difference between the Area (% of total land area) in Argentina and Area (% of total land area) in Uzbekistan?
Keep it short and to the point. -8.8. In the year 2010, what is the difference between the Area (% of total land area) of Sweden and Area (% of total land area) of Uzbekistan?
Make the answer very short. -55.18. In the year 2011, what is the difference between the Area (% of total land area) in European Union and Area (% of total land area) in Argentina?
Provide a short and direct response. -9.99. In the year 2011, what is the difference between the Area (% of total land area) in European Union and Area (% of total land area) in Sweden?
Make the answer very short. 36.72. In the year 2011, what is the difference between the Area (% of total land area) of European Union and Area (% of total land area) of Uzbekistan?
Provide a succinct answer. -18.41. In the year 2011, what is the difference between the Area (% of total land area) in Argentina and Area (% of total land area) in Sweden?
Your response must be concise. 46.71. In the year 2011, what is the difference between the Area (% of total land area) of Argentina and Area (% of total land area) of Uzbekistan?
Provide a short and direct response. -8.42. In the year 2011, what is the difference between the Area (% of total land area) of Sweden and Area (% of total land area) of Uzbekistan?
Your answer should be very brief. -55.13. In the year 2012, what is the difference between the Area (% of total land area) of European Union and Area (% of total land area) of Argentina?
Offer a terse response. -10.51. In the year 2012, what is the difference between the Area (% of total land area) of European Union and Area (% of total land area) of Sweden?
Offer a very short reply. 36.54. In the year 2012, what is the difference between the Area (% of total land area) in European Union and Area (% of total land area) in Uzbekistan?
Your answer should be compact. -18.86. In the year 2012, what is the difference between the Area (% of total land area) of Argentina and Area (% of total land area) of Sweden?
Keep it short and to the point. 47.05. In the year 2012, what is the difference between the Area (% of total land area) of Argentina and Area (% of total land area) of Uzbekistan?
Offer a very short reply. -8.34. In the year 2012, what is the difference between the Area (% of total land area) in Sweden and Area (% of total land area) in Uzbekistan?
Ensure brevity in your answer.  -55.4. What is the ratio of the Area (% of total land area) of Argentina in 2005 to that in 2006?
Make the answer very short. 0.98. What is the ratio of the Area (% of total land area) of Sweden in 2005 to that in 2006?
Your answer should be compact. 1.02. What is the ratio of the Area (% of total land area) in European Union in 2005 to that in 2007?
Ensure brevity in your answer.  1.02. What is the ratio of the Area (% of total land area) in Argentina in 2005 to that in 2007?
Your answer should be very brief. 0.96. What is the ratio of the Area (% of total land area) of Sweden in 2005 to that in 2007?
Give a very brief answer. 1.03. What is the ratio of the Area (% of total land area) of European Union in 2005 to that in 2008?
Your response must be concise. 1.01. What is the ratio of the Area (% of total land area) of Argentina in 2005 to that in 2008?
Make the answer very short. 0.96. What is the ratio of the Area (% of total land area) in Sweden in 2005 to that in 2008?
Provide a succinct answer. 1.04. What is the ratio of the Area (% of total land area) in Uzbekistan in 2005 to that in 2008?
Your answer should be compact. 1. What is the ratio of the Area (% of total land area) of European Union in 2005 to that in 2009?
Your response must be concise. 1.02. What is the ratio of the Area (% of total land area) in Argentina in 2005 to that in 2009?
Provide a short and direct response. 0.96. What is the ratio of the Area (% of total land area) in Sweden in 2005 to that in 2009?
Provide a succinct answer. 1.04. What is the ratio of the Area (% of total land area) of European Union in 2005 to that in 2010?
Ensure brevity in your answer.  1.03. What is the ratio of the Area (% of total land area) of Argentina in 2005 to that in 2010?
Your answer should be very brief. 0.93. What is the ratio of the Area (% of total land area) of Sweden in 2005 to that in 2010?
Your answer should be very brief. 1.04. What is the ratio of the Area (% of total land area) of Uzbekistan in 2005 to that in 2010?
Provide a short and direct response. 1. What is the ratio of the Area (% of total land area) of Argentina in 2005 to that in 2011?
Offer a terse response. 0.93. What is the ratio of the Area (% of total land area) of Sweden in 2005 to that in 2011?
Make the answer very short. 1.05. What is the ratio of the Area (% of total land area) of European Union in 2005 to that in 2012?
Offer a very short reply. 1.04. What is the ratio of the Area (% of total land area) in Argentina in 2005 to that in 2012?
Give a very brief answer. 0.92. What is the ratio of the Area (% of total land area) in Sweden in 2005 to that in 2012?
Your answer should be very brief. 1.05. What is the ratio of the Area (% of total land area) in Uzbekistan in 2005 to that in 2012?
Make the answer very short. 1. What is the ratio of the Area (% of total land area) of European Union in 2006 to that in 2007?
Make the answer very short. 1.01. What is the ratio of the Area (% of total land area) of Argentina in 2006 to that in 2007?
Your response must be concise. 0.98. What is the ratio of the Area (% of total land area) in Sweden in 2006 to that in 2007?
Offer a terse response. 1.01. What is the ratio of the Area (% of total land area) in European Union in 2006 to that in 2008?
Keep it short and to the point. 1.01. What is the ratio of the Area (% of total land area) of Argentina in 2006 to that in 2008?
Ensure brevity in your answer.  0.98. What is the ratio of the Area (% of total land area) in Sweden in 2006 to that in 2008?
Ensure brevity in your answer.  1.02. What is the ratio of the Area (% of total land area) of European Union in 2006 to that in 2009?
Offer a very short reply. 1.02. What is the ratio of the Area (% of total land area) of Argentina in 2006 to that in 2009?
Your answer should be compact. 0.98. What is the ratio of the Area (% of total land area) of Sweden in 2006 to that in 2009?
Provide a short and direct response. 1.03. What is the ratio of the Area (% of total land area) in European Union in 2006 to that in 2010?
Provide a succinct answer. 1.02. What is the ratio of the Area (% of total land area) of Argentina in 2006 to that in 2010?
Offer a terse response. 0.96. What is the ratio of the Area (% of total land area) in Sweden in 2006 to that in 2010?
Offer a terse response. 1.03. What is the ratio of the Area (% of total land area) of European Union in 2006 to that in 2011?
Give a very brief answer. 1.03. What is the ratio of the Area (% of total land area) in Argentina in 2006 to that in 2011?
Offer a terse response. 0.95. What is the ratio of the Area (% of total land area) in Sweden in 2006 to that in 2011?
Provide a short and direct response. 1.03. What is the ratio of the Area (% of total land area) in Uzbekistan in 2006 to that in 2011?
Your answer should be compact. 1. What is the ratio of the Area (% of total land area) in European Union in 2006 to that in 2012?
Give a very brief answer. 1.03. What is the ratio of the Area (% of total land area) of Argentina in 2006 to that in 2012?
Offer a terse response. 0.95. What is the ratio of the Area (% of total land area) of Sweden in 2006 to that in 2012?
Offer a terse response. 1.03. What is the ratio of the Area (% of total land area) of Uzbekistan in 2006 to that in 2012?
Provide a succinct answer. 1. What is the ratio of the Area (% of total land area) of European Union in 2007 to that in 2008?
Give a very brief answer. 1. What is the ratio of the Area (% of total land area) in Argentina in 2007 to that in 2008?
Your response must be concise. 1. What is the ratio of the Area (% of total land area) in Sweden in 2007 to that in 2008?
Your answer should be very brief. 1.01. What is the ratio of the Area (% of total land area) of Sweden in 2007 to that in 2009?
Ensure brevity in your answer.  1.02. What is the ratio of the Area (% of total land area) in Uzbekistan in 2007 to that in 2009?
Your response must be concise. 1. What is the ratio of the Area (% of total land area) in European Union in 2007 to that in 2010?
Offer a terse response. 1.01. What is the ratio of the Area (% of total land area) of Argentina in 2007 to that in 2010?
Your answer should be very brief. 0.98. What is the ratio of the Area (% of total land area) of Sweden in 2007 to that in 2010?
Provide a succinct answer. 1.02. What is the ratio of the Area (% of total land area) in Uzbekistan in 2007 to that in 2010?
Offer a terse response. 1. What is the ratio of the Area (% of total land area) in European Union in 2007 to that in 2011?
Your answer should be compact. 1.02. What is the ratio of the Area (% of total land area) in Argentina in 2007 to that in 2011?
Your answer should be very brief. 0.97. What is the ratio of the Area (% of total land area) in Sweden in 2007 to that in 2011?
Your answer should be compact. 1.02. What is the ratio of the Area (% of total land area) in Uzbekistan in 2007 to that in 2011?
Offer a very short reply. 1. What is the ratio of the Area (% of total land area) in European Union in 2007 to that in 2012?
Keep it short and to the point. 1.02. What is the ratio of the Area (% of total land area) in Argentina in 2007 to that in 2012?
Ensure brevity in your answer.  0.96. What is the ratio of the Area (% of total land area) in Sweden in 2007 to that in 2012?
Keep it short and to the point. 1.02. What is the ratio of the Area (% of total land area) in Uzbekistan in 2007 to that in 2012?
Provide a short and direct response. 1. What is the ratio of the Area (% of total land area) in Uzbekistan in 2008 to that in 2009?
Offer a terse response. 1. What is the ratio of the Area (% of total land area) of European Union in 2008 to that in 2010?
Give a very brief answer. 1.01. What is the ratio of the Area (% of total land area) in Argentina in 2008 to that in 2010?
Give a very brief answer. 0.98. What is the ratio of the Area (% of total land area) of Uzbekistan in 2008 to that in 2010?
Provide a succinct answer. 1. What is the ratio of the Area (% of total land area) of European Union in 2008 to that in 2011?
Your answer should be compact. 1.02. What is the ratio of the Area (% of total land area) of Argentina in 2008 to that in 2011?
Your answer should be compact. 0.97. What is the ratio of the Area (% of total land area) in Sweden in 2008 to that in 2011?
Provide a short and direct response. 1.01. What is the ratio of the Area (% of total land area) of European Union in 2008 to that in 2012?
Offer a very short reply. 1.02. What is the ratio of the Area (% of total land area) of Argentina in 2008 to that in 2012?
Provide a short and direct response. 0.97. What is the ratio of the Area (% of total land area) of Sweden in 2008 to that in 2012?
Make the answer very short. 1.01. What is the ratio of the Area (% of total land area) of Uzbekistan in 2008 to that in 2012?
Provide a short and direct response. 1. What is the ratio of the Area (% of total land area) of European Union in 2009 to that in 2010?
Offer a very short reply. 1.01. What is the ratio of the Area (% of total land area) of Argentina in 2009 to that in 2010?
Provide a succinct answer. 0.97. What is the ratio of the Area (% of total land area) of Uzbekistan in 2009 to that in 2010?
Your answer should be very brief. 1. What is the ratio of the Area (% of total land area) in European Union in 2009 to that in 2011?
Make the answer very short. 1.01. What is the ratio of the Area (% of total land area) of Argentina in 2009 to that in 2011?
Give a very brief answer. 0.97. What is the ratio of the Area (% of total land area) in Sweden in 2009 to that in 2011?
Your answer should be compact. 1. What is the ratio of the Area (% of total land area) in Uzbekistan in 2009 to that in 2011?
Offer a very short reply. 1. What is the ratio of the Area (% of total land area) of European Union in 2009 to that in 2012?
Make the answer very short. 1.02. What is the ratio of the Area (% of total land area) of Argentina in 2009 to that in 2012?
Your answer should be very brief. 0.96. What is the ratio of the Area (% of total land area) of Sweden in 2009 to that in 2012?
Provide a short and direct response. 1. What is the ratio of the Area (% of total land area) in Sweden in 2010 to that in 2011?
Ensure brevity in your answer.  1.01. What is the ratio of the Area (% of total land area) in Uzbekistan in 2010 to that in 2011?
Keep it short and to the point. 1. What is the ratio of the Area (% of total land area) of European Union in 2010 to that in 2012?
Keep it short and to the point. 1.01. What is the ratio of the Area (% of total land area) of Argentina in 2010 to that in 2012?
Keep it short and to the point. 0.99. What is the ratio of the Area (% of total land area) of Uzbekistan in 2010 to that in 2012?
Your answer should be very brief. 1. What is the ratio of the Area (% of total land area) of Sweden in 2011 to that in 2012?
Keep it short and to the point. 1. What is the ratio of the Area (% of total land area) in Uzbekistan in 2011 to that in 2012?
Your response must be concise. 1. What is the difference between the highest and the second highest Area (% of total land area) of European Union?
Give a very brief answer. 0.19. What is the difference between the highest and the second highest Area (% of total land area) in Argentina?
Offer a very short reply. 0.36. What is the difference between the highest and the second highest Area (% of total land area) of Sweden?
Offer a very short reply. 0.13. What is the difference between the highest and the second highest Area (% of total land area) in Uzbekistan?
Offer a very short reply. 0.02. What is the difference between the highest and the lowest Area (% of total land area) in European Union?
Provide a short and direct response. 1.63. What is the difference between the highest and the lowest Area (% of total land area) in Argentina?
Give a very brief answer. 4.19. What is the difference between the highest and the lowest Area (% of total land area) of Sweden?
Offer a very short reply. 0.37. What is the difference between the highest and the lowest Area (% of total land area) in Uzbekistan?
Keep it short and to the point. 0.31. 